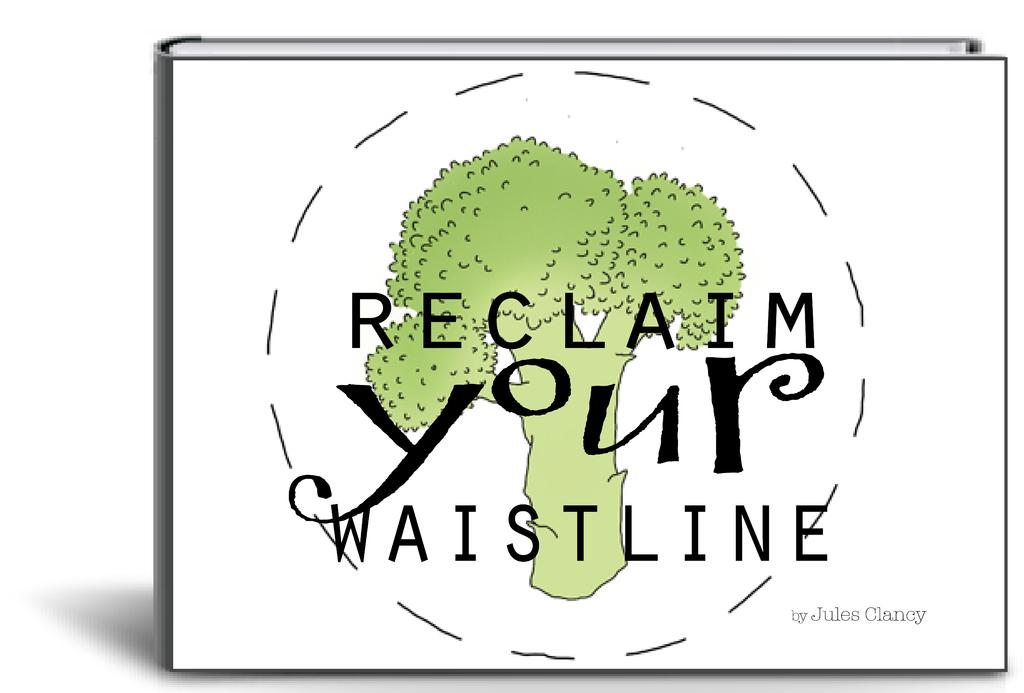What type of image is being described? The image is a graphic. What object can be seen in the graphic? There is a book in the image. What is depicted on the book? The book has a painting of a tree on it. What else can be found on the book? There are texts on the cover page of the book. What color is the vase on the cover of the book? There is no vase present on the cover of the book; it features a painting of a tree and texts. 